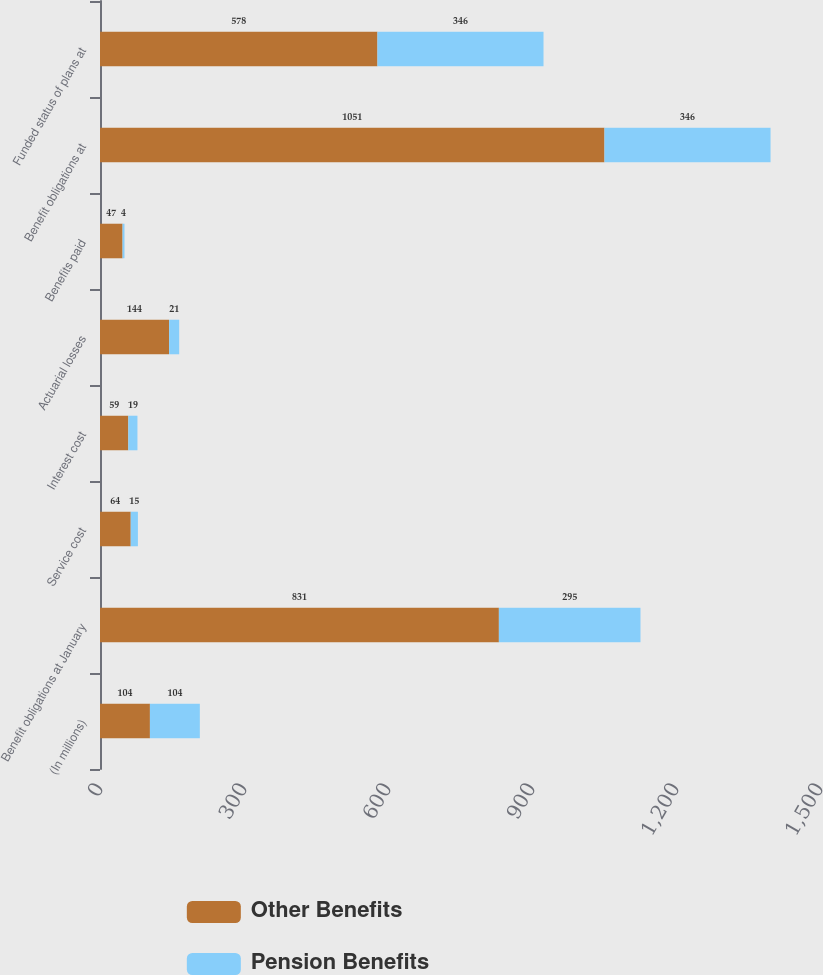Convert chart. <chart><loc_0><loc_0><loc_500><loc_500><stacked_bar_chart><ecel><fcel>(In millions)<fcel>Benefit obligations at January<fcel>Service cost<fcel>Interest cost<fcel>Actuarial losses<fcel>Benefits paid<fcel>Benefit obligations at<fcel>Funded status of plans at<nl><fcel>Other Benefits<fcel>104<fcel>831<fcel>64<fcel>59<fcel>144<fcel>47<fcel>1051<fcel>578<nl><fcel>Pension Benefits<fcel>104<fcel>295<fcel>15<fcel>19<fcel>21<fcel>4<fcel>346<fcel>346<nl></chart> 